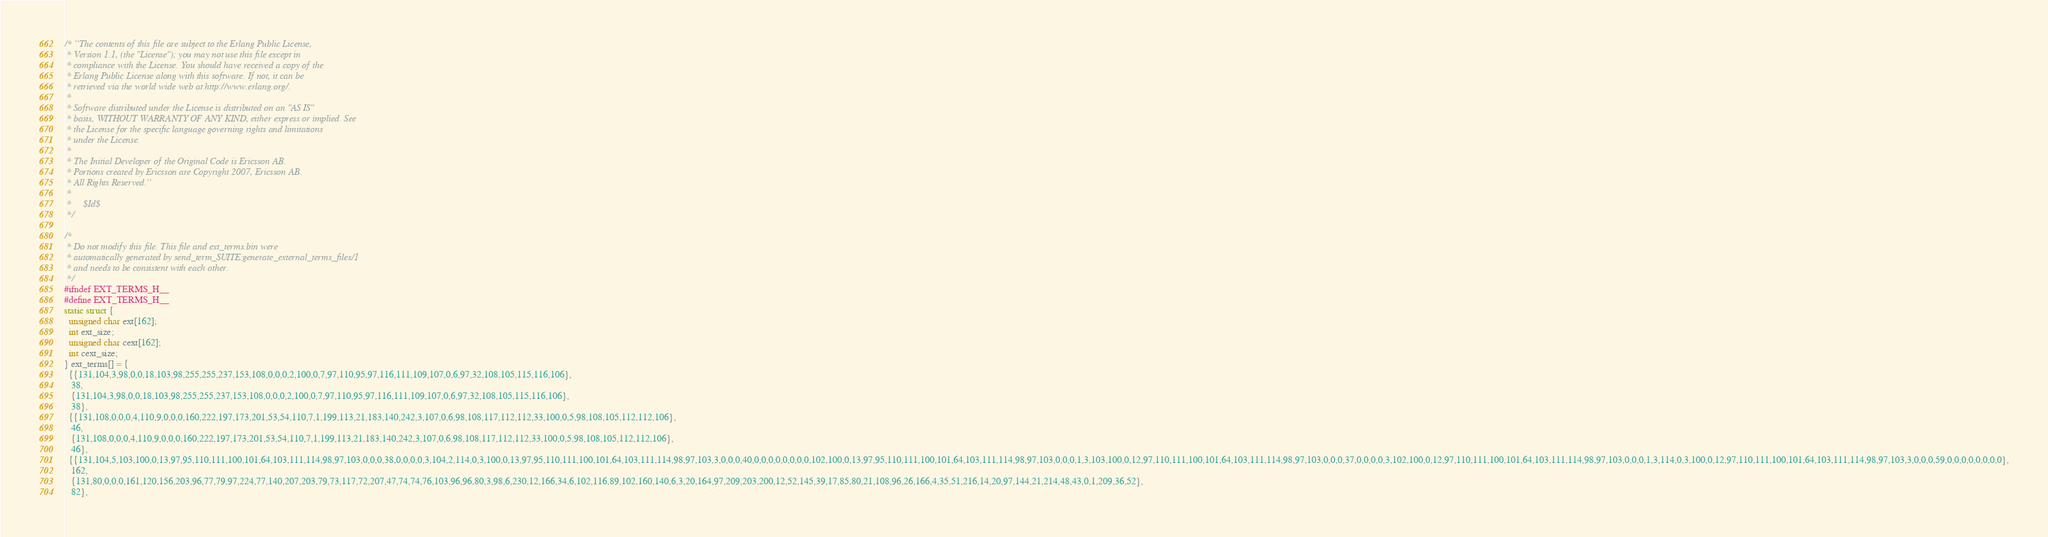Convert code to text. <code><loc_0><loc_0><loc_500><loc_500><_C_>/* ``The contents of this file are subject to the Erlang Public License,
 * Version 1.1, (the "License"); you may not use this file except in
 * compliance with the License. You should have received a copy of the
 * Erlang Public License along with this software. If not, it can be
 * retrieved via the world wide web at http://www.erlang.org/.
 * 
 * Software distributed under the License is distributed on an "AS IS"
 * basis, WITHOUT WARRANTY OF ANY KIND, either express or implied. See
 * the License for the specific language governing rights and limitations
 * under the License.
 * 
 * The Initial Developer of the Original Code is Ericsson AB.
 * Portions created by Ericsson are Copyright 2007, Ericsson AB.
 * All Rights Reserved.''
 * 
 *     $Id$
 */

/*
 * Do not modify this file. This file and ext_terms.bin were
 * automatically generated by send_term_SUITE:generate_external_terms_files/1
 * and needs to be consistent with each other.
 */
#ifndef EXT_TERMS_H__
#define EXT_TERMS_H__
static struct {
  unsigned char ext[162];
  int ext_size;
  unsigned char cext[162];
  int cext_size;
} ext_terms[] = {
  {{131,104,3,98,0,0,18,103,98,255,255,237,153,108,0,0,0,2,100,0,7,97,110,95,97,116,111,109,107,0,6,97,32,108,105,115,116,106},
   38,
   {131,104,3,98,0,0,18,103,98,255,255,237,153,108,0,0,0,2,100,0,7,97,110,95,97,116,111,109,107,0,6,97,32,108,105,115,116,106},
   38},
  {{131,108,0,0,0,4,110,9,0,0,0,160,222,197,173,201,53,54,110,7,1,199,113,21,183,140,242,3,107,0,6,98,108,117,112,112,33,100,0,5,98,108,105,112,112,106},
   46,
   {131,108,0,0,0,4,110,9,0,0,0,160,222,197,173,201,53,54,110,7,1,199,113,21,183,140,242,3,107,0,6,98,108,117,112,112,33,100,0,5,98,108,105,112,112,106},
   46},
  {{131,104,5,103,100,0,13,97,95,110,111,100,101,64,103,111,114,98,97,103,0,0,0,38,0,0,0,0,3,104,2,114,0,3,100,0,13,97,95,110,111,100,101,64,103,111,114,98,97,103,3,0,0,0,40,0,0,0,0,0,0,0,0,102,100,0,13,97,95,110,111,100,101,64,103,111,114,98,97,103,0,0,0,1,3,103,100,0,12,97,110,111,100,101,64,103,111,114,98,97,103,0,0,0,37,0,0,0,0,3,102,100,0,12,97,110,111,100,101,64,103,111,114,98,97,103,0,0,0,1,3,114,0,3,100,0,12,97,110,111,100,101,64,103,111,114,98,97,103,3,0,0,0,59,0,0,0,0,0,0,0,0},
   162,
   {131,80,0,0,0,161,120,156,203,96,77,79,97,224,77,140,207,203,79,73,117,72,207,47,74,74,76,103,96,96,80,3,98,6,230,12,166,34,6,102,116,89,102,160,140,6,3,20,164,97,209,203,200,12,52,145,39,17,85,80,21,108,96,26,166,4,35,51,216,14,20,97,144,21,214,48,43,0,1,209,36,52},
   82},</code> 